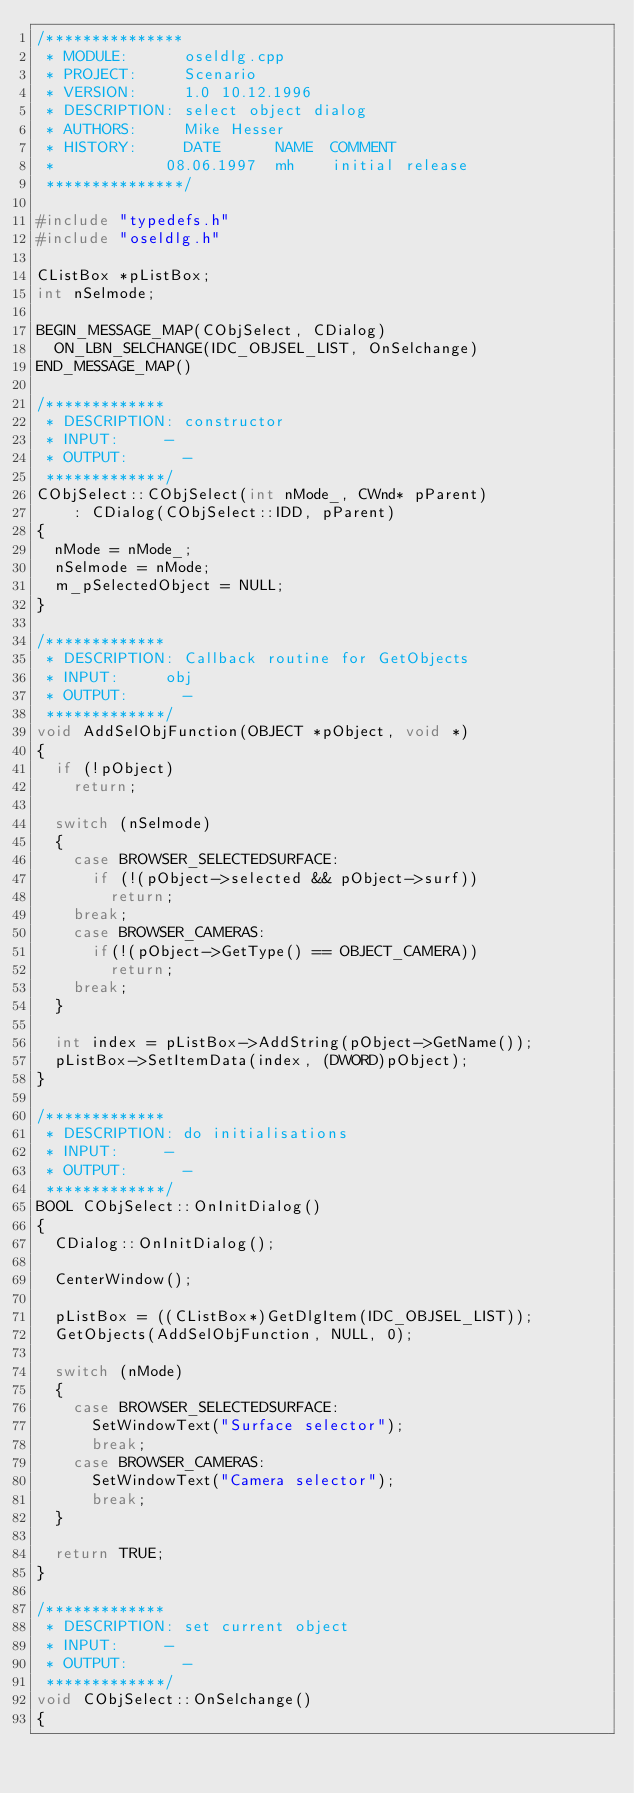Convert code to text. <code><loc_0><loc_0><loc_500><loc_500><_C++_>/***************
 * MODULE:			oseldlg.cpp
 * PROJECT:			Scenario
 * VERSION:			1.0 10.12.1996
 * DESCRIPTION:	select object dialog
 * AUTHORS:			Mike Hesser
 * HISTORY:			DATE			NAME	COMMENT
 *						08.06.1997	mh		initial release
 ***************/

#include "typedefs.h"
#include "oseldlg.h"

CListBox *pListBox;
int nSelmode;

BEGIN_MESSAGE_MAP(CObjSelect, CDialog)
	ON_LBN_SELCHANGE(IDC_OBJSEL_LIST, OnSelchange)
END_MESSAGE_MAP()

/*************
 * DESCRIPTION:	constructor
 * INPUT:			-
 * OUTPUT:			-
 *************/
CObjSelect::CObjSelect(int nMode_, CWnd* pParent)
    : CDialog(CObjSelect::IDD, pParent)
{
	nMode = nMode_;
	nSelmode = nMode;
	m_pSelectedObject = NULL;
}

/*************
 * DESCRIPTION:	Callback routine for GetObjects
 * INPUT:			obj
 * OUTPUT:			-
 *************/
void AddSelObjFunction(OBJECT *pObject, void *)
{
	if (!pObject)
		return;

	switch (nSelmode)
	{
		case BROWSER_SELECTEDSURFACE:
			if (!(pObject->selected && pObject->surf))
				return;
		break;
		case BROWSER_CAMERAS:
			if(!(pObject->GetType() == OBJECT_CAMERA))
				return;
		break;
	}

	int index = pListBox->AddString(pObject->GetName());
	pListBox->SetItemData(index, (DWORD)pObject);
}

/*************
 * DESCRIPTION:	do initialisations
 * INPUT:			-
 * OUTPUT:			-
 *************/
BOOL CObjSelect::OnInitDialog()
{
	CDialog::OnInitDialog();

	CenterWindow();

	pListBox = ((CListBox*)GetDlgItem(IDC_OBJSEL_LIST));
	GetObjects(AddSelObjFunction, NULL, 0);

	switch (nMode)
	{
		case BROWSER_SELECTEDSURFACE:
			SetWindowText("Surface selector");
			break;
		case BROWSER_CAMERAS:
			SetWindowText("Camera selector");
			break;
	}

	return TRUE;
}

/*************
 * DESCRIPTION:	set current object
 * INPUT:			-
 * OUTPUT:			-
 *************/
void CObjSelect::OnSelchange() 
{</code> 